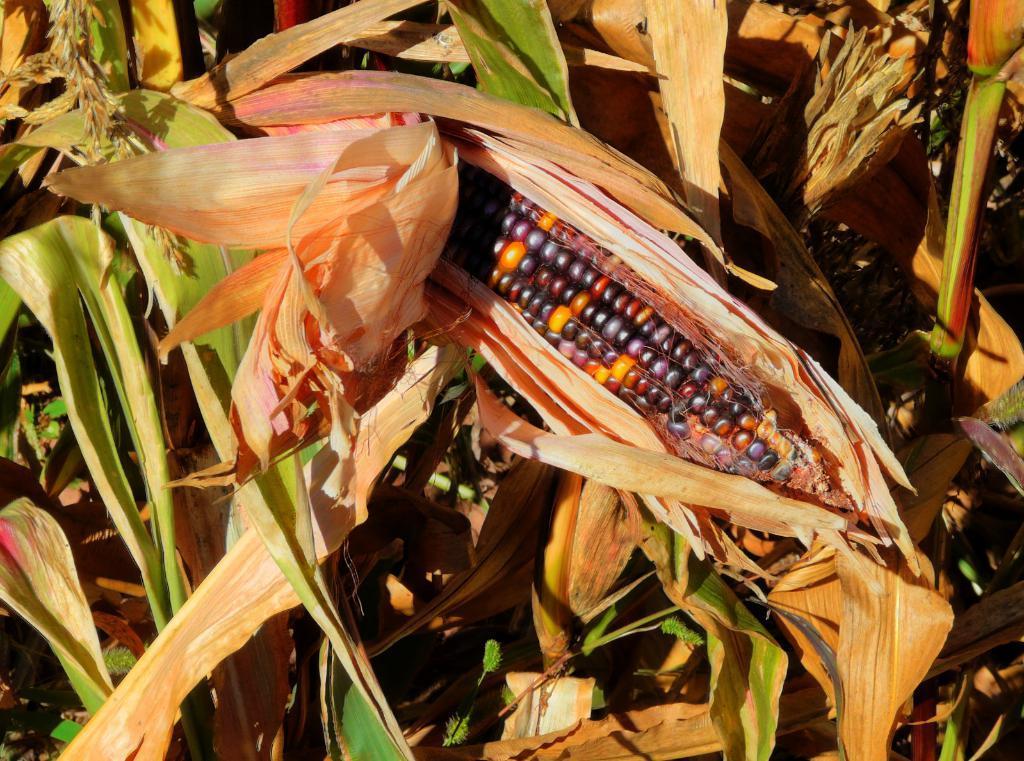Could you give a brief overview of what you see in this image? In this image I see the leaves and I see the corn over here which is of orange, black and violet in color. 